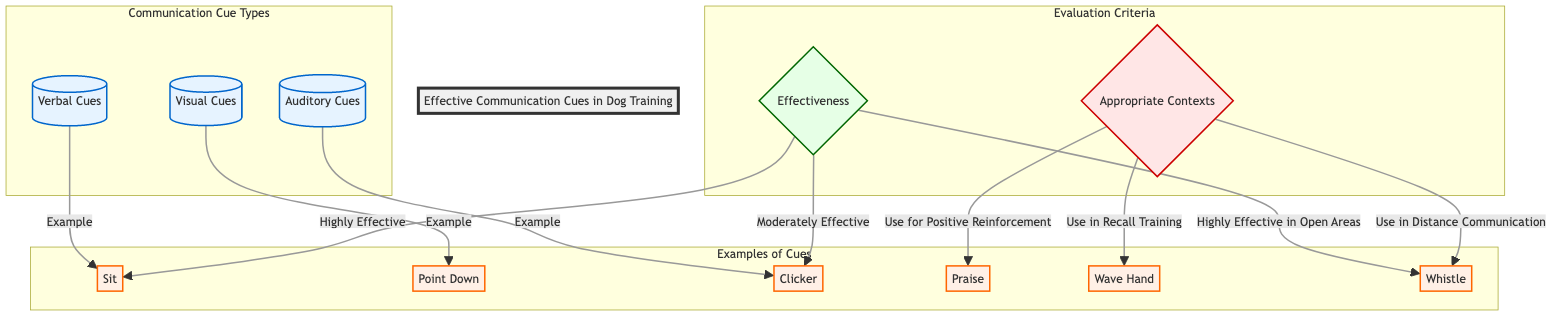What are the three types of communication cues identified in the diagram? The diagram lists "Verbal Cues," "Visual Cues," and "Auditory Cues" as the three types of communication cues under the "Communication Cue Types" section.
Answer: Verbal Cues, Visual Cues, Auditory Cues Which cue is associated with “Sit”? The cue "Sit" is listed under the "Examples of Cues" section, directly linked with "Verbal Cues" as an example.
Answer: Sit How many highly effective cues are noted in the "Effectiveness" section? The diagram indicates that “Sit” is highly effective, while “Whistle” is also mentioned in the context of being highly effective in open areas. Counting these, we find two instances classified as highly effective.
Answer: 2 What is the appropriate context for using the “Wave Hand” cue? The context for using the "Wave Hand" is not explicitly stated in the diagram, so I will infer that it is a visual cue generally useful in various training scenarios. However, it doesn't focus on a specific context as other cues do.
Answer: Not specified Which cue is noted for use in recall training? According to the diagram, the cue "Clicker" is directly associated with the context of positive reinforcement and identified as a cue used specifically for recall training.
Answer: Clicker What is the effectiveness of the "Clicker" cue? The diagram classifies the "Clicker" cue as "Moderately Effective." It is associated with the effectiveness node under the examples.
Answer: Moderately Effective What is the effectiveness of the “Whistle” cue? The cue "Whistle" is adjacent to an effectiveness classification stating it is "Highly Effective in Open Areas." This indicates its effectiveness varies by environment, thus qualifying it as highly effective under certain contexts.
Answer: Highly Effective in Open Areas Which cues are classified under "Examples of Cues"? The cues included in the "Examples of Cues" section are "Sit," "Point Down," "Clicker," "Praise," "Wave Hand," and "Whistle." Listing these shows all the examples provided in the diagram.
Answer: Sit, Point Down, Clicker, Praise, Wave Hand, Whistle 